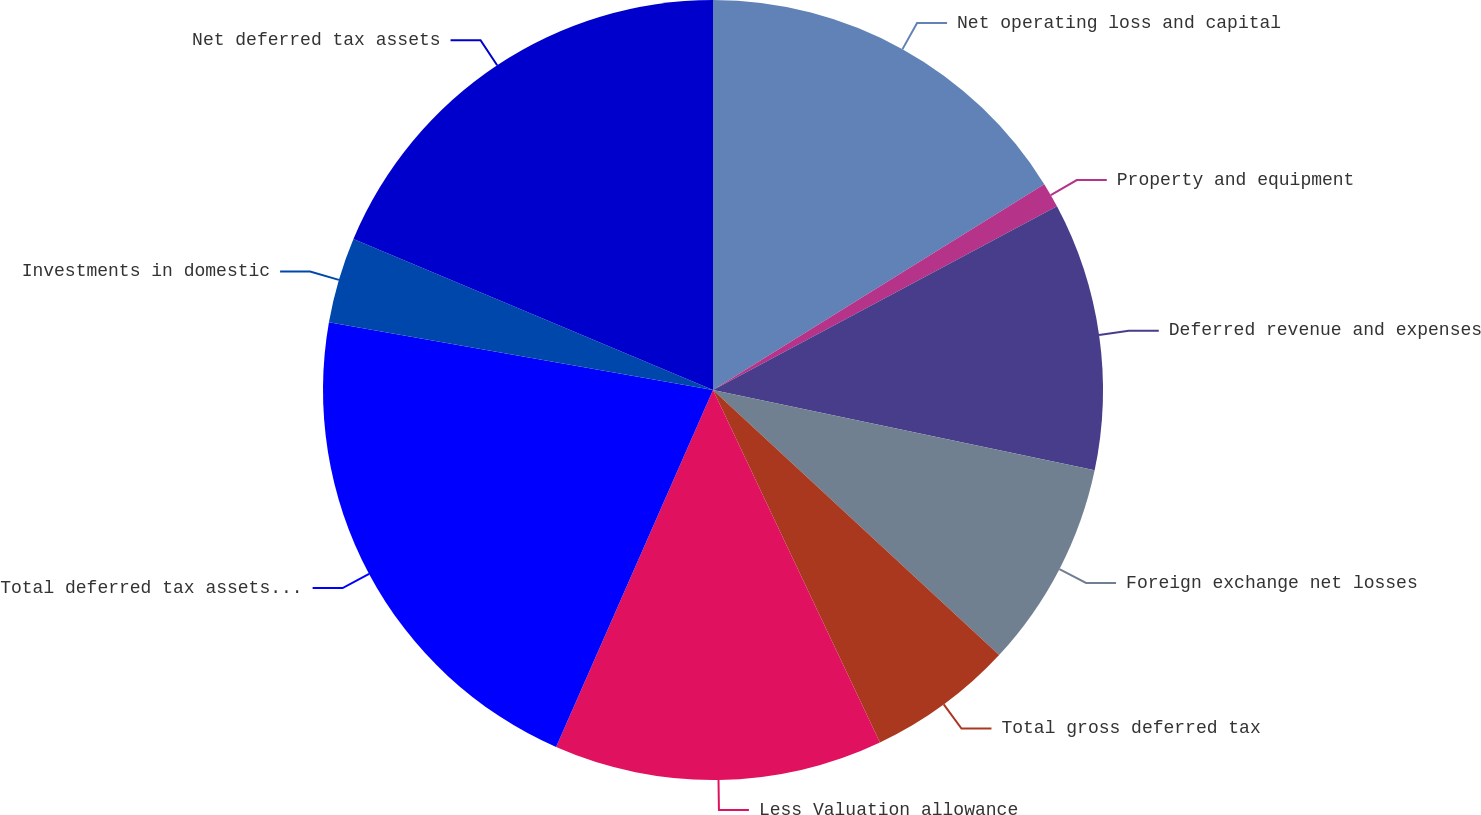<chart> <loc_0><loc_0><loc_500><loc_500><pie_chart><fcel>Net operating loss and capital<fcel>Property and equipment<fcel>Deferred revenue and expenses<fcel>Foreign exchange net losses<fcel>Total gross deferred tax<fcel>Less Valuation allowance<fcel>Total deferred tax assets net<fcel>Investments in domestic<fcel>Net deferred tax assets<nl><fcel>16.15%<fcel>1.04%<fcel>11.11%<fcel>8.59%<fcel>6.07%<fcel>13.63%<fcel>21.19%<fcel>3.55%<fcel>18.67%<nl></chart> 